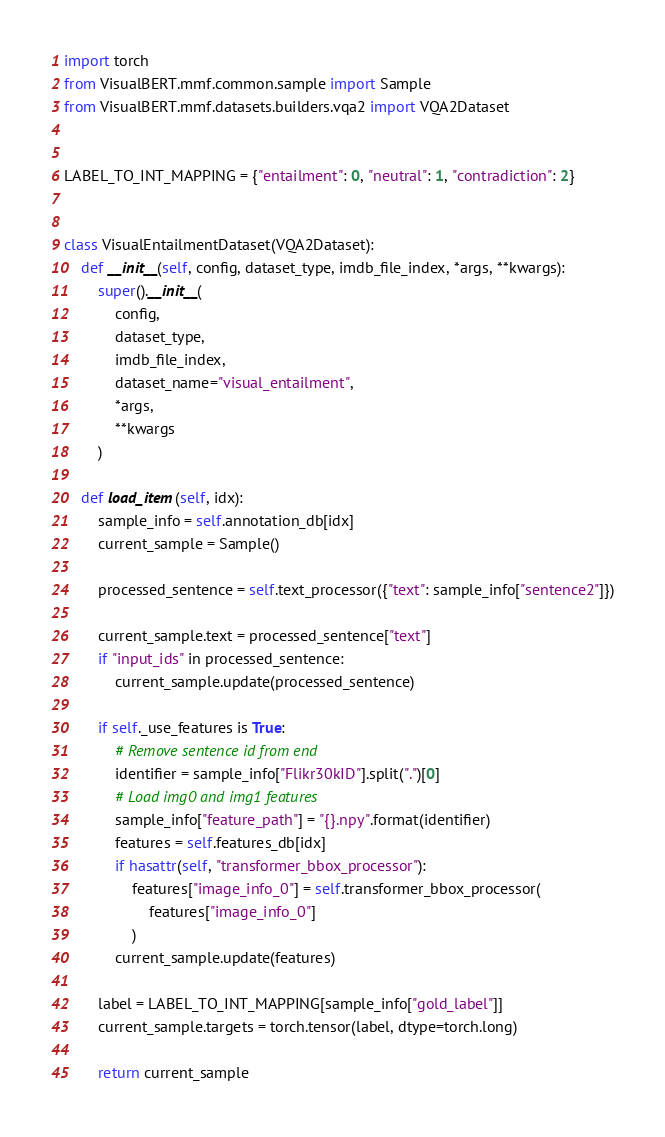Convert code to text. <code><loc_0><loc_0><loc_500><loc_500><_Python_>import torch
from VisualBERT.mmf.common.sample import Sample
from VisualBERT.mmf.datasets.builders.vqa2 import VQA2Dataset


LABEL_TO_INT_MAPPING = {"entailment": 0, "neutral": 1, "contradiction": 2}


class VisualEntailmentDataset(VQA2Dataset):
    def __init__(self, config, dataset_type, imdb_file_index, *args, **kwargs):
        super().__init__(
            config,
            dataset_type,
            imdb_file_index,
            dataset_name="visual_entailment",
            *args,
            **kwargs
        )

    def load_item(self, idx):
        sample_info = self.annotation_db[idx]
        current_sample = Sample()

        processed_sentence = self.text_processor({"text": sample_info["sentence2"]})

        current_sample.text = processed_sentence["text"]
        if "input_ids" in processed_sentence:
            current_sample.update(processed_sentence)

        if self._use_features is True:
            # Remove sentence id from end
            identifier = sample_info["Flikr30kID"].split(".")[0]
            # Load img0 and img1 features
            sample_info["feature_path"] = "{}.npy".format(identifier)
            features = self.features_db[idx]
            if hasattr(self, "transformer_bbox_processor"):
                features["image_info_0"] = self.transformer_bbox_processor(
                    features["image_info_0"]
                )
            current_sample.update(features)

        label = LABEL_TO_INT_MAPPING[sample_info["gold_label"]]
        current_sample.targets = torch.tensor(label, dtype=torch.long)

        return current_sample
</code> 